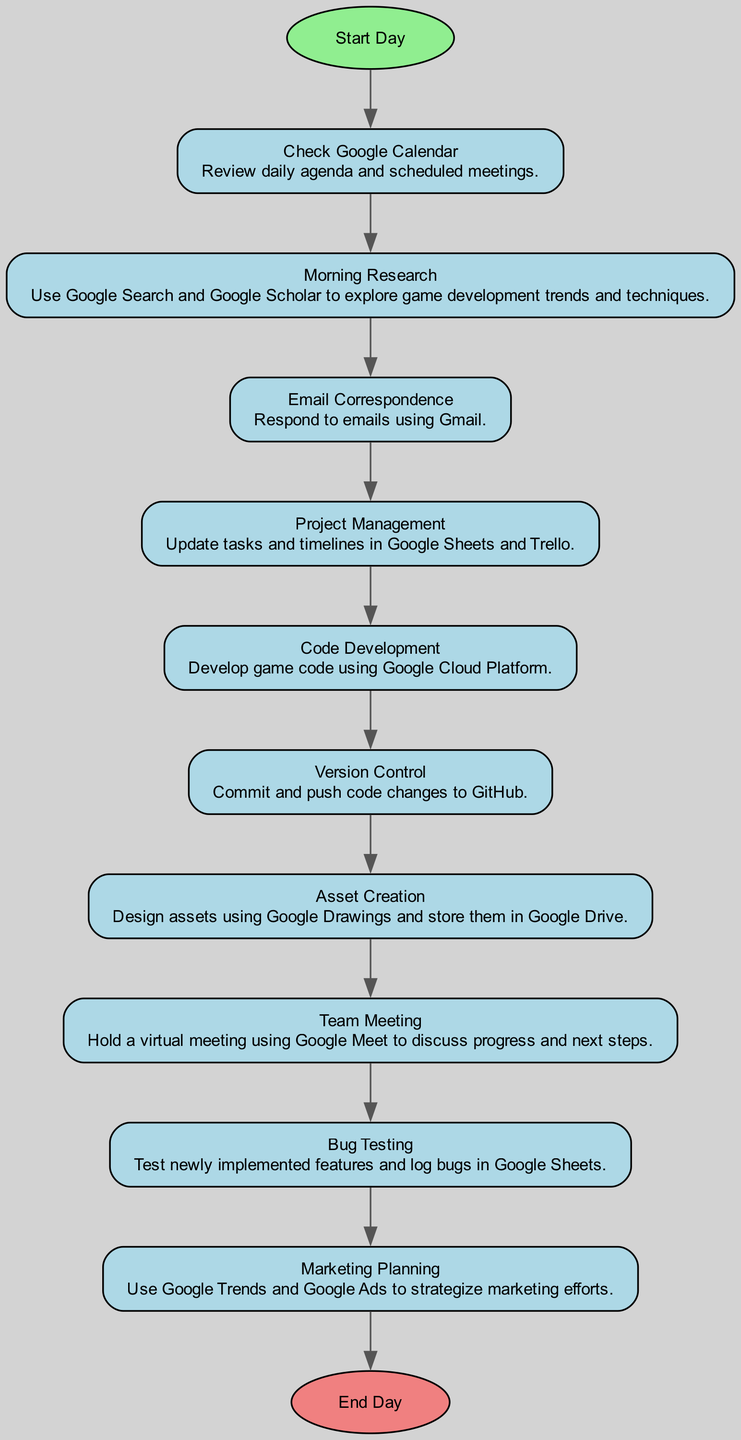What is the first activity in the diagram? The diagram begins at the "Start Day" node and immediately connects to the first activity, which is "Check Google Calendar."
Answer: Check Google Calendar How many activities are listed in the diagram? The diagram lists a total of 10 activities, starting from "Check Google Calendar" and ending with "Marketing Planning."
Answer: 10 What activity comes after "Code Development"? Following "Code Development," the next activity is "Version Control," which is connected directly in the flow of the diagram.
Answer: Version Control Which tool is used for asset creation according to the diagram? The specific activity "Asset Creation" mentions the use of "Google Drawings" for designing assets, as indicated in the description of that activity.
Answer: Google Drawings What are the two tools used in "Project Management"? In the activity "Project Management," both "Google Sheets" and "Trello" are listed as tools utilized for updating tasks and timelines, indicating a combination of both platforms.
Answer: Google Sheets and Trello What is the final step in the daily workflow? The last activity before concluding the workflow is "Marketing Planning," which leads to the "End Day" node, marking the completion of the day’s activities.
Answer: End Day How does "Morning Research" relate to "Bug Testing"? "Morning Research" precedes "Email Correspondence," "Project Management," "Code Development," and several other activities before it eventually reaches "Bug Testing." This flow means that multiple activities occur between the two.
Answer: Multiple activities In which activity are email correspondence tasks performed? The activity explicitly named "Email Correspondence" details the action of responding to emails, making it clear this is where email tasks take place.
Answer: Email Correspondence What color is the start node in the diagram? The "Start Day" node is highlighted in light green, as specified in the node attributes for visual identification.
Answer: Light green 